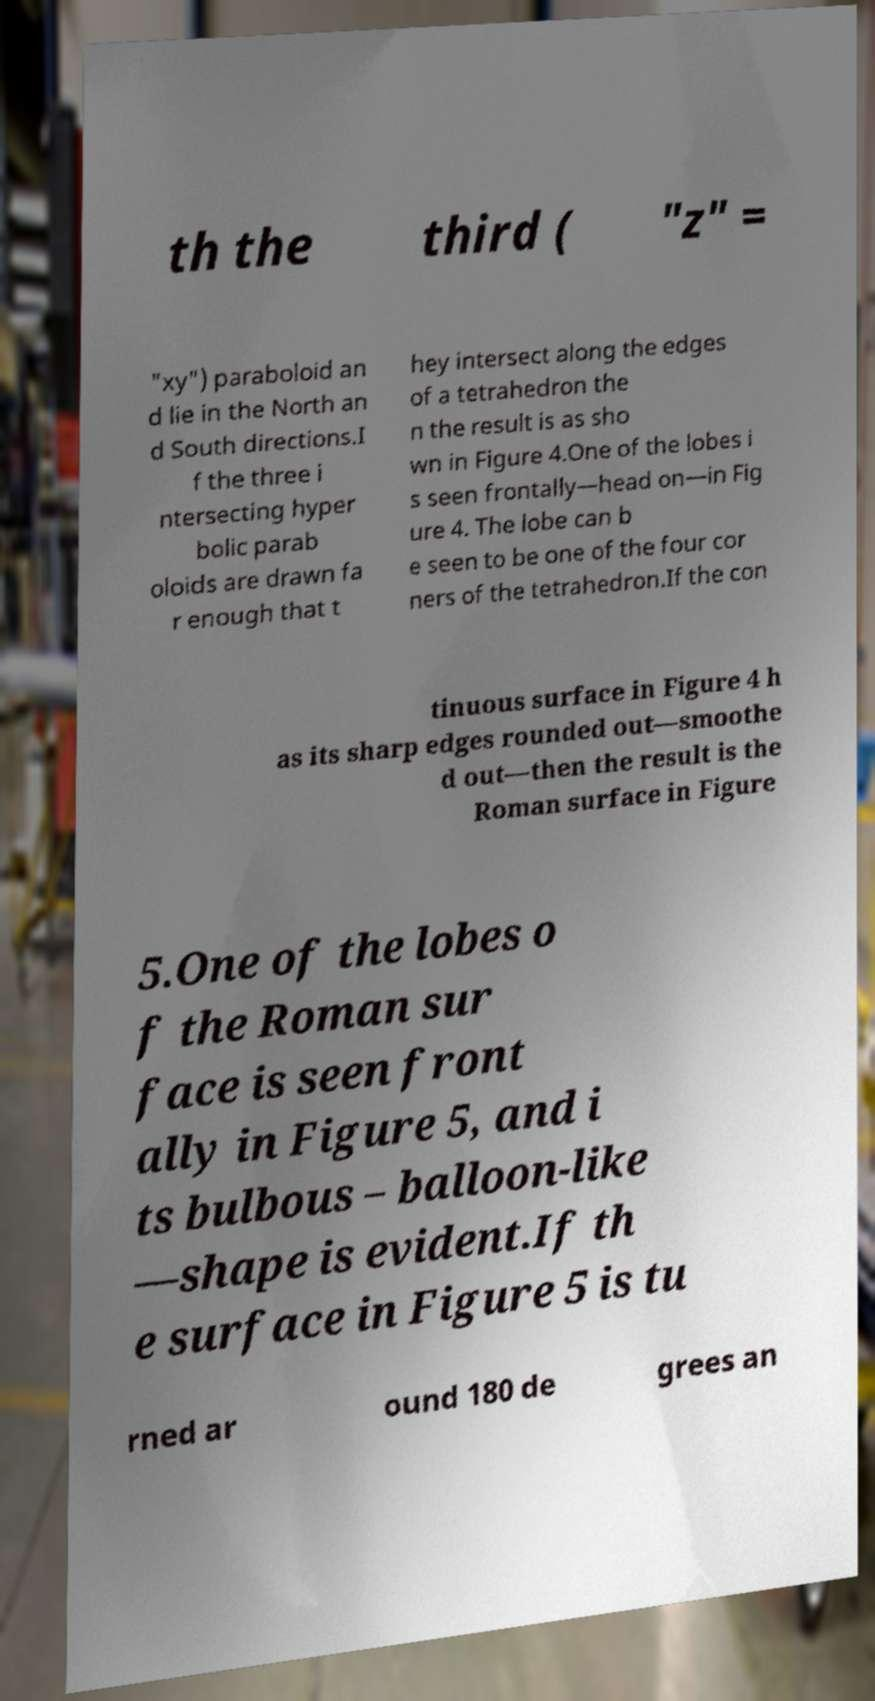Please read and relay the text visible in this image. What does it say? th the third ( "z" = "xy") paraboloid an d lie in the North an d South directions.I f the three i ntersecting hyper bolic parab oloids are drawn fa r enough that t hey intersect along the edges of a tetrahedron the n the result is as sho wn in Figure 4.One of the lobes i s seen frontally—head on—in Fig ure 4. The lobe can b e seen to be one of the four cor ners of the tetrahedron.If the con tinuous surface in Figure 4 h as its sharp edges rounded out—smoothe d out—then the result is the Roman surface in Figure 5.One of the lobes o f the Roman sur face is seen front ally in Figure 5, and i ts bulbous – balloon-like —shape is evident.If th e surface in Figure 5 is tu rned ar ound 180 de grees an 